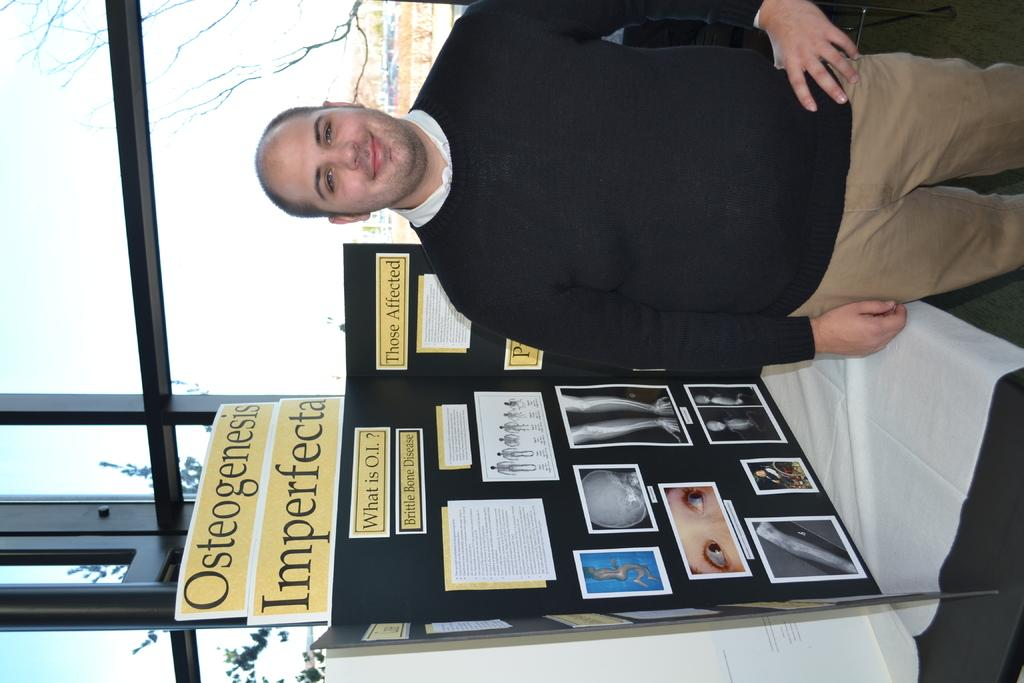<image>
Summarize the visual content of the image. A man standing next to a trifold with the words osteogenesis imperfecta behind him. 